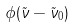<formula> <loc_0><loc_0><loc_500><loc_500>\phi ( \tilde { \nu } - \tilde { \nu } _ { 0 } )</formula> 